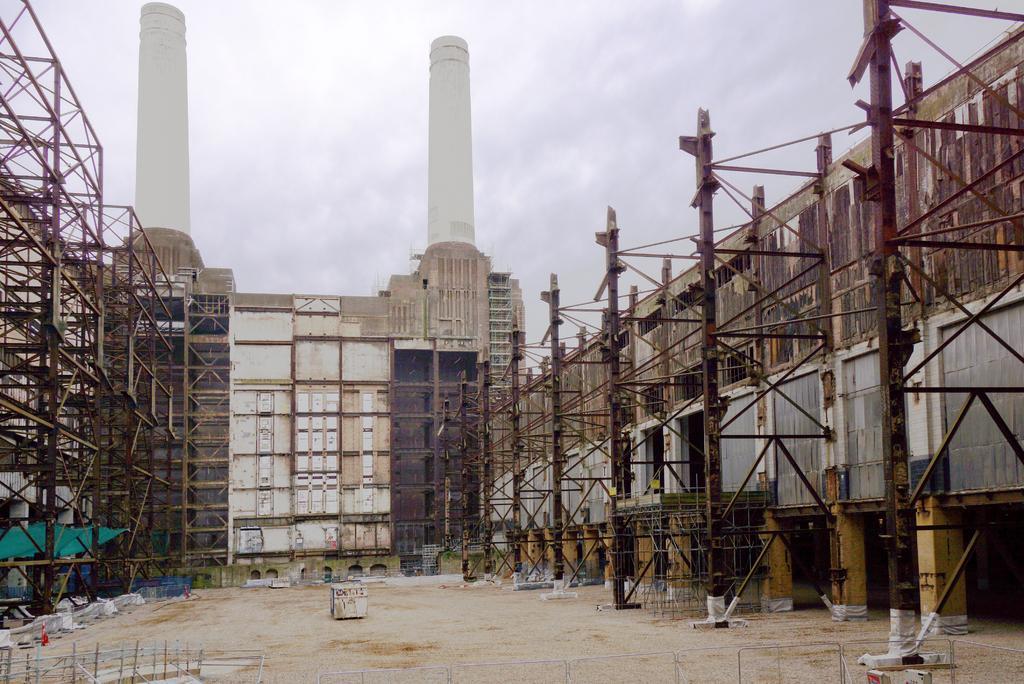Describe this image in one or two sentences. In the center of the image there is a building. On the right we can see poles. On the left there are railings. In the background there is sky. 